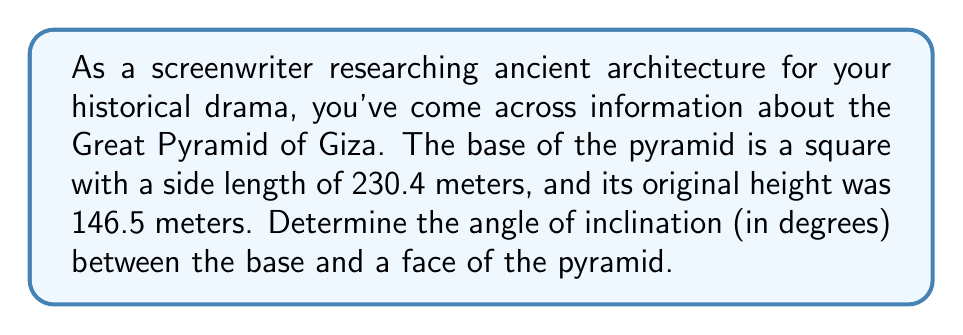Solve this math problem. To solve this problem, we'll use trigonometry. Let's break it down step-by-step:

1. Visualize the pyramid:
   [asy]
   import geometry;
   
   size(200);
   
   pair A = (0,0), B = (4,0), C = (2,3);
   draw(A--B--C--cycle);
   draw(A--(2,0), dashed);
   
   label("230.4 m", (2,0), S);
   label("146.5 m", (2,1.5), E);
   label("θ", (0.3,0.3), NW);
   
   dot("A", A, SW);
   dot("B", B, SE);
   dot("C", C, N);
   [/asy]

2. We need to find the angle θ between the base and the face of the pyramid.

3. In the right triangle formed by half of the base, the height, and the face:
   - The adjacent side to θ is half of the base length: $\frac{230.4}{2} = 115.2$ meters
   - The opposite side to θ is the height: 146.5 meters

4. We can use the tangent function to find θ:

   $$\tan(\theta) = \frac{\text{opposite}}{\text{adjacent}} = \frac{146.5}{115.2}$$

5. To solve for θ, we use the inverse tangent (arctan or tan⁻¹):

   $$\theta = \tan^{-1}\left(\frac{146.5}{115.2}\right)$$

6. Using a calculator or computer:

   $$\theta \approx 51.84^\circ$$

Therefore, the angle of inclination between the base and a face of the Great Pyramid of Giza is approximately 51.84°.
Answer: $51.84^\circ$ (rounded to two decimal places) 